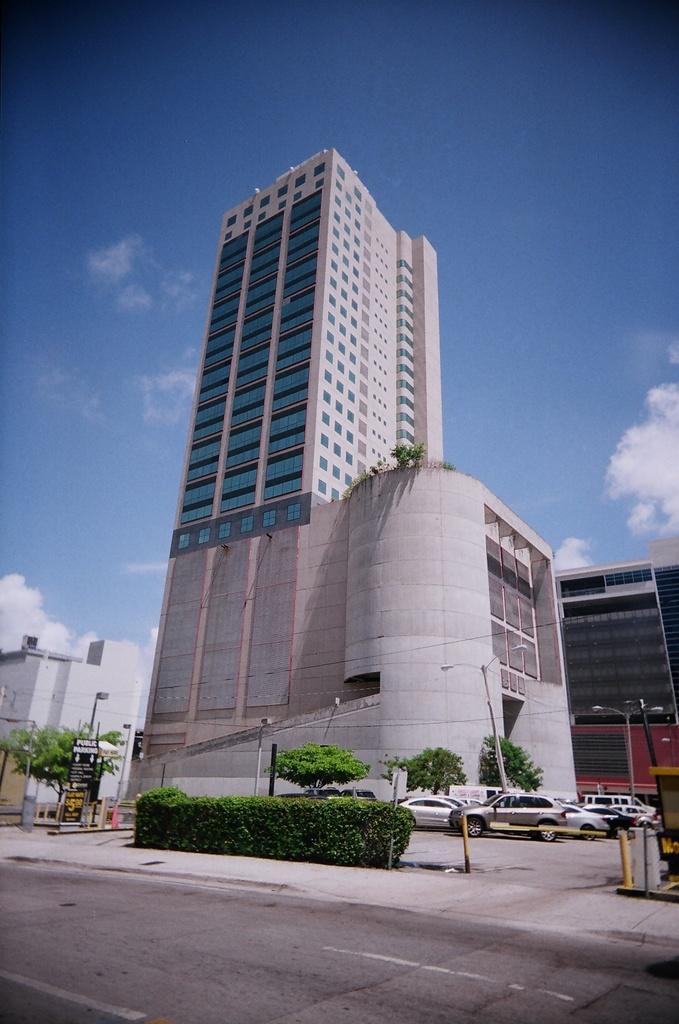In one or two sentences, can you explain what this image depicts? In this image at the bottom we can see vehicles on the road, plants, trees, poles, hoardings. In the background there are buildings, glass doors and clouds in the sky. 